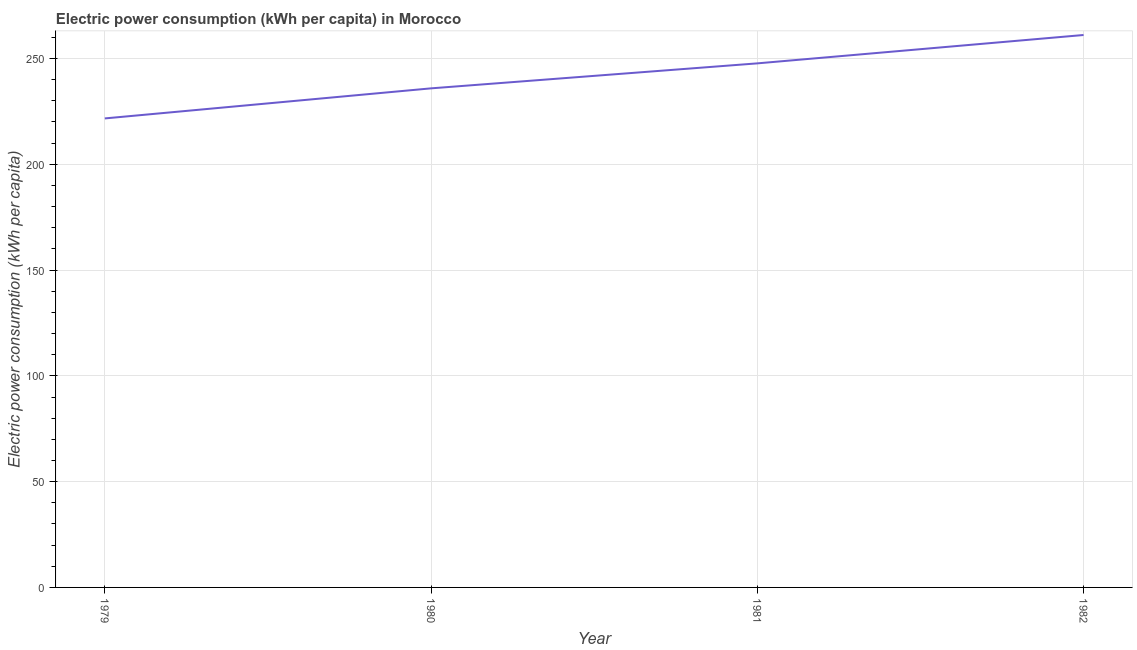What is the electric power consumption in 1980?
Make the answer very short. 235.9. Across all years, what is the maximum electric power consumption?
Keep it short and to the point. 261.12. Across all years, what is the minimum electric power consumption?
Make the answer very short. 221.69. In which year was the electric power consumption minimum?
Your answer should be very brief. 1979. What is the sum of the electric power consumption?
Your response must be concise. 966.42. What is the difference between the electric power consumption in 1979 and 1982?
Give a very brief answer. -39.43. What is the average electric power consumption per year?
Your response must be concise. 241.61. What is the median electric power consumption?
Provide a short and direct response. 241.81. Do a majority of the years between 1982 and 1980 (inclusive) have electric power consumption greater than 230 kWh per capita?
Your answer should be very brief. No. What is the ratio of the electric power consumption in 1981 to that in 1982?
Your answer should be very brief. 0.95. Is the difference between the electric power consumption in 1979 and 1980 greater than the difference between any two years?
Your response must be concise. No. What is the difference between the highest and the second highest electric power consumption?
Give a very brief answer. 13.41. What is the difference between the highest and the lowest electric power consumption?
Ensure brevity in your answer.  39.43. In how many years, is the electric power consumption greater than the average electric power consumption taken over all years?
Your response must be concise. 2. Does the electric power consumption monotonically increase over the years?
Your response must be concise. Yes. How many lines are there?
Your answer should be compact. 1. What is the difference between two consecutive major ticks on the Y-axis?
Your answer should be compact. 50. Are the values on the major ticks of Y-axis written in scientific E-notation?
Your answer should be compact. No. Does the graph contain grids?
Keep it short and to the point. Yes. What is the title of the graph?
Give a very brief answer. Electric power consumption (kWh per capita) in Morocco. What is the label or title of the X-axis?
Make the answer very short. Year. What is the label or title of the Y-axis?
Offer a terse response. Electric power consumption (kWh per capita). What is the Electric power consumption (kWh per capita) in 1979?
Ensure brevity in your answer.  221.69. What is the Electric power consumption (kWh per capita) of 1980?
Give a very brief answer. 235.9. What is the Electric power consumption (kWh per capita) of 1981?
Your answer should be very brief. 247.71. What is the Electric power consumption (kWh per capita) of 1982?
Ensure brevity in your answer.  261.12. What is the difference between the Electric power consumption (kWh per capita) in 1979 and 1980?
Your response must be concise. -14.21. What is the difference between the Electric power consumption (kWh per capita) in 1979 and 1981?
Offer a terse response. -26.02. What is the difference between the Electric power consumption (kWh per capita) in 1979 and 1982?
Your response must be concise. -39.43. What is the difference between the Electric power consumption (kWh per capita) in 1980 and 1981?
Offer a very short reply. -11.81. What is the difference between the Electric power consumption (kWh per capita) in 1980 and 1982?
Give a very brief answer. -25.22. What is the difference between the Electric power consumption (kWh per capita) in 1981 and 1982?
Your answer should be very brief. -13.41. What is the ratio of the Electric power consumption (kWh per capita) in 1979 to that in 1981?
Offer a terse response. 0.9. What is the ratio of the Electric power consumption (kWh per capita) in 1979 to that in 1982?
Ensure brevity in your answer.  0.85. What is the ratio of the Electric power consumption (kWh per capita) in 1980 to that in 1981?
Offer a very short reply. 0.95. What is the ratio of the Electric power consumption (kWh per capita) in 1980 to that in 1982?
Your answer should be very brief. 0.9. What is the ratio of the Electric power consumption (kWh per capita) in 1981 to that in 1982?
Provide a succinct answer. 0.95. 